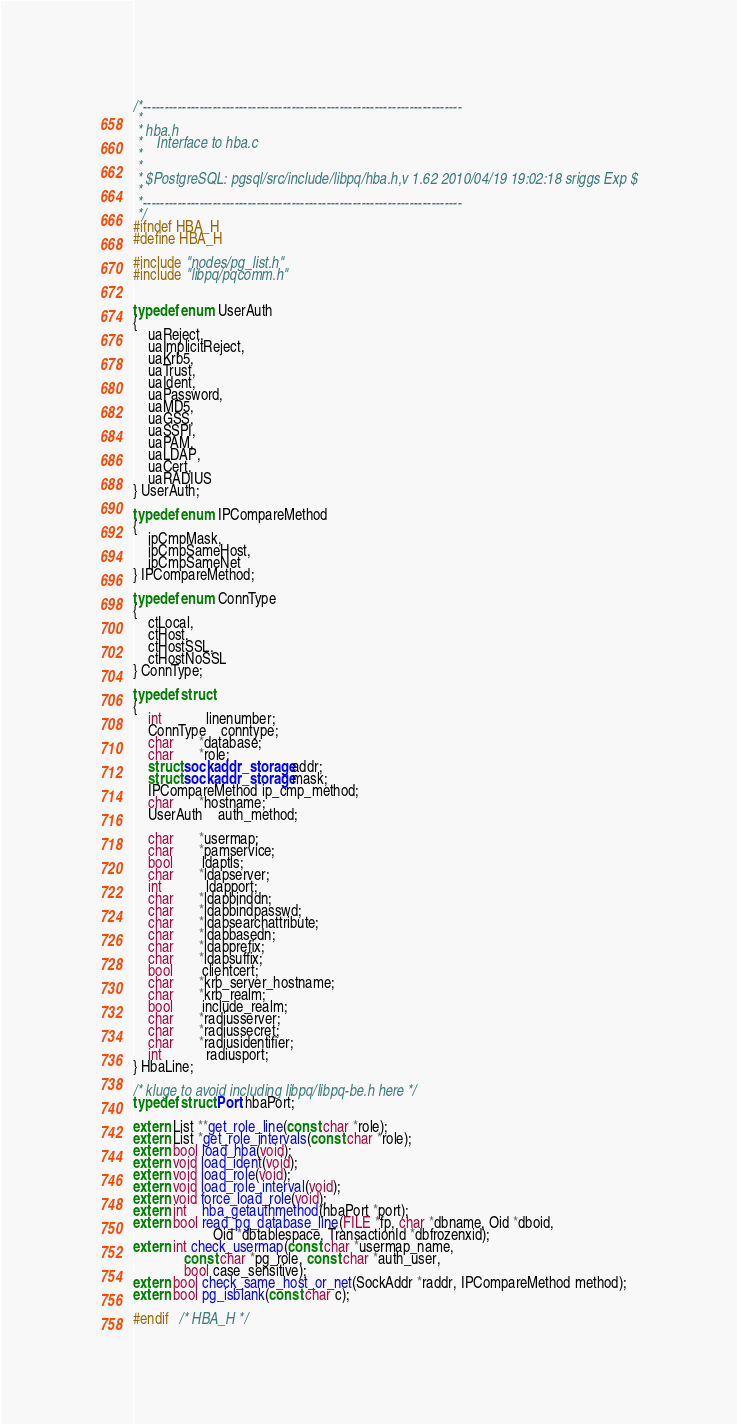Convert code to text. <code><loc_0><loc_0><loc_500><loc_500><_C_>/*-------------------------------------------------------------------------
 *
 * hba.h
 *	  Interface to hba.c
 *
 *
 * $PostgreSQL: pgsql/src/include/libpq/hba.h,v 1.62 2010/04/19 19:02:18 sriggs Exp $
 *
 *-------------------------------------------------------------------------
 */
#ifndef HBA_H
#define HBA_H

#include "nodes/pg_list.h"
#include "libpq/pqcomm.h"


typedef enum UserAuth
{
	uaReject,
	uaImplicitReject,
	uaKrb5,
	uaTrust,
	uaIdent,
	uaPassword,
	uaMD5,
	uaGSS,
	uaSSPI,
	uaPAM,
	uaLDAP,
	uaCert,
	uaRADIUS
} UserAuth;

typedef enum IPCompareMethod
{
	ipCmpMask,
	ipCmpSameHost,
	ipCmpSameNet
} IPCompareMethod;

typedef enum ConnType
{
	ctLocal,
	ctHost,
	ctHostSSL,
	ctHostNoSSL
} ConnType;

typedef struct
{
	int			linenumber;
	ConnType	conntype;
	char	   *database;
	char	   *role;
	struct sockaddr_storage addr;
	struct sockaddr_storage mask;
	IPCompareMethod ip_cmp_method;
	char	   *hostname;
	UserAuth	auth_method;

	char	   *usermap;
	char	   *pamservice;
	bool		ldaptls;
	char	   *ldapserver;
	int			ldapport;
	char	   *ldapbinddn;
	char	   *ldapbindpasswd;
	char	   *ldapsearchattribute;
	char	   *ldapbasedn;
	char	   *ldapprefix;
	char	   *ldapsuffix;
	bool		clientcert;
	char	   *krb_server_hostname;
	char	   *krb_realm;
	bool		include_realm;
	char	   *radiusserver;
	char	   *radiussecret;
	char	   *radiusidentifier;
	int			radiusport;
} HbaLine;

/* kluge to avoid including libpq/libpq-be.h here */
typedef struct Port hbaPort;

extern List **get_role_line(const char *role);
extern List *get_role_intervals(const char *role);
extern bool load_hba(void);
extern void load_ident(void);
extern void load_role(void);
extern void load_role_interval(void);
extern void force_load_role(void);
extern int	hba_getauthmethod(hbaPort *port);
extern bool read_pg_database_line(FILE *fp, char *dbname, Oid *dboid,
					  Oid *dbtablespace, TransactionId *dbfrozenxid);
extern int check_usermap(const char *usermap_name,
			  const char *pg_role, const char *auth_user,
			  bool case_sensitive);
extern bool check_same_host_or_net(SockAddr *raddr, IPCompareMethod method);
extern bool pg_isblank(const char c);

#endif   /* HBA_H */
</code> 